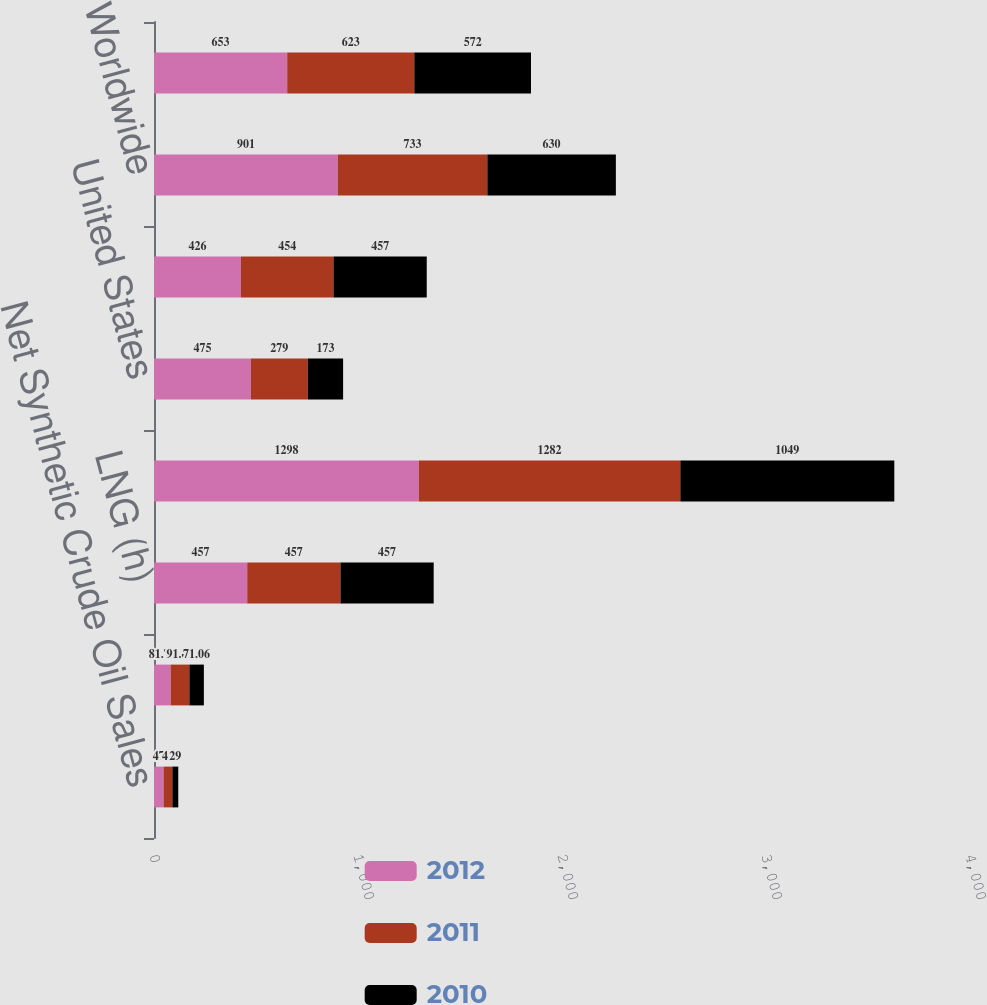Convert chart to OTSL. <chart><loc_0><loc_0><loc_500><loc_500><stacked_bar_chart><ecel><fcel>Net Synthetic Crude Oil Sales<fcel>Synthetic Crude Oil Average<fcel>LNG (h)<fcel>Methanol<fcel>United States<fcel>International<fcel>Worldwide<fcel>Canada<nl><fcel>2012<fcel>47<fcel>81.72<fcel>457<fcel>1298<fcel>475<fcel>426<fcel>901<fcel>653<nl><fcel>2011<fcel>43<fcel>91.65<fcel>457<fcel>1282<fcel>279<fcel>454<fcel>733<fcel>623<nl><fcel>2010<fcel>29<fcel>71.06<fcel>457<fcel>1049<fcel>173<fcel>457<fcel>630<fcel>572<nl></chart> 